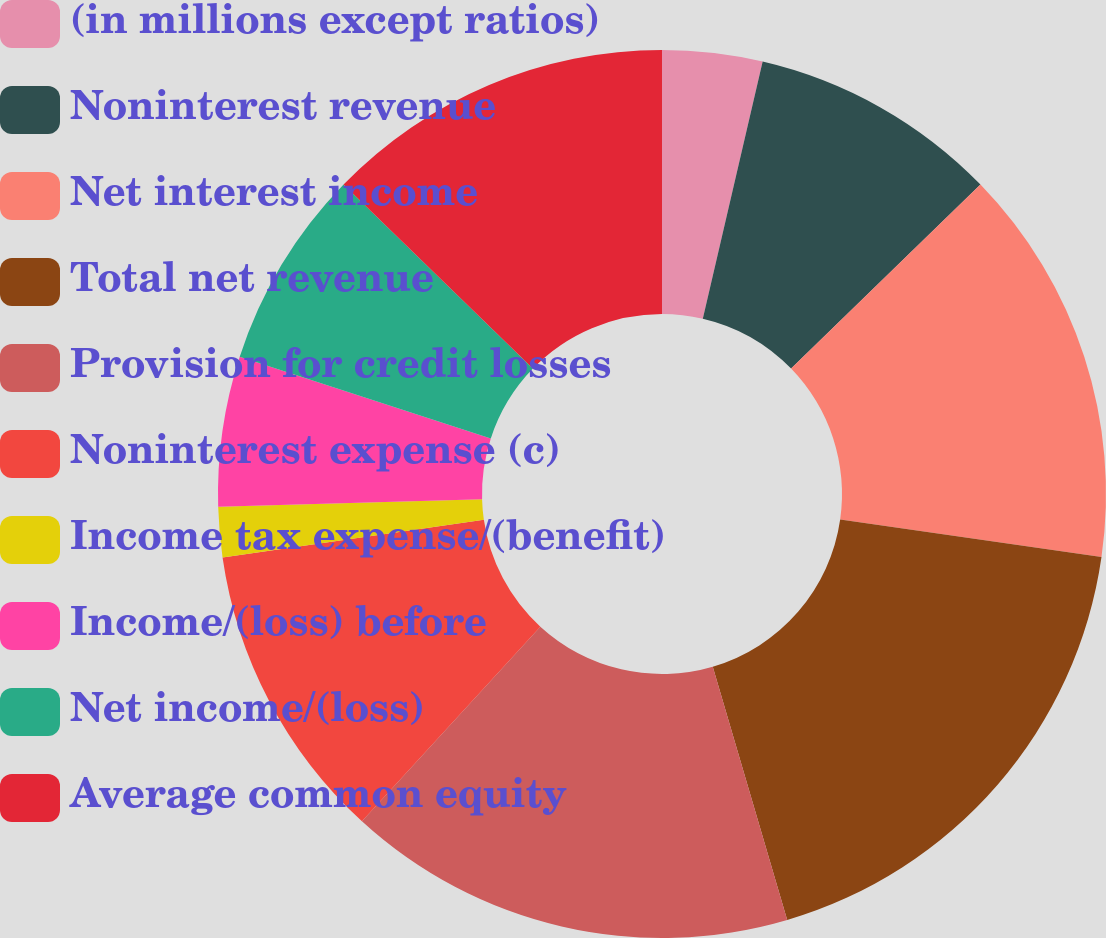Convert chart to OTSL. <chart><loc_0><loc_0><loc_500><loc_500><pie_chart><fcel>(in millions except ratios)<fcel>Noninterest revenue<fcel>Net interest income<fcel>Total net revenue<fcel>Provision for credit losses<fcel>Noninterest expense (c)<fcel>Income tax expense/(benefit)<fcel>Income/(loss) before<fcel>Net income/(loss)<fcel>Average common equity<nl><fcel>3.64%<fcel>9.09%<fcel>14.54%<fcel>18.18%<fcel>16.36%<fcel>10.91%<fcel>1.82%<fcel>5.46%<fcel>7.27%<fcel>12.73%<nl></chart> 